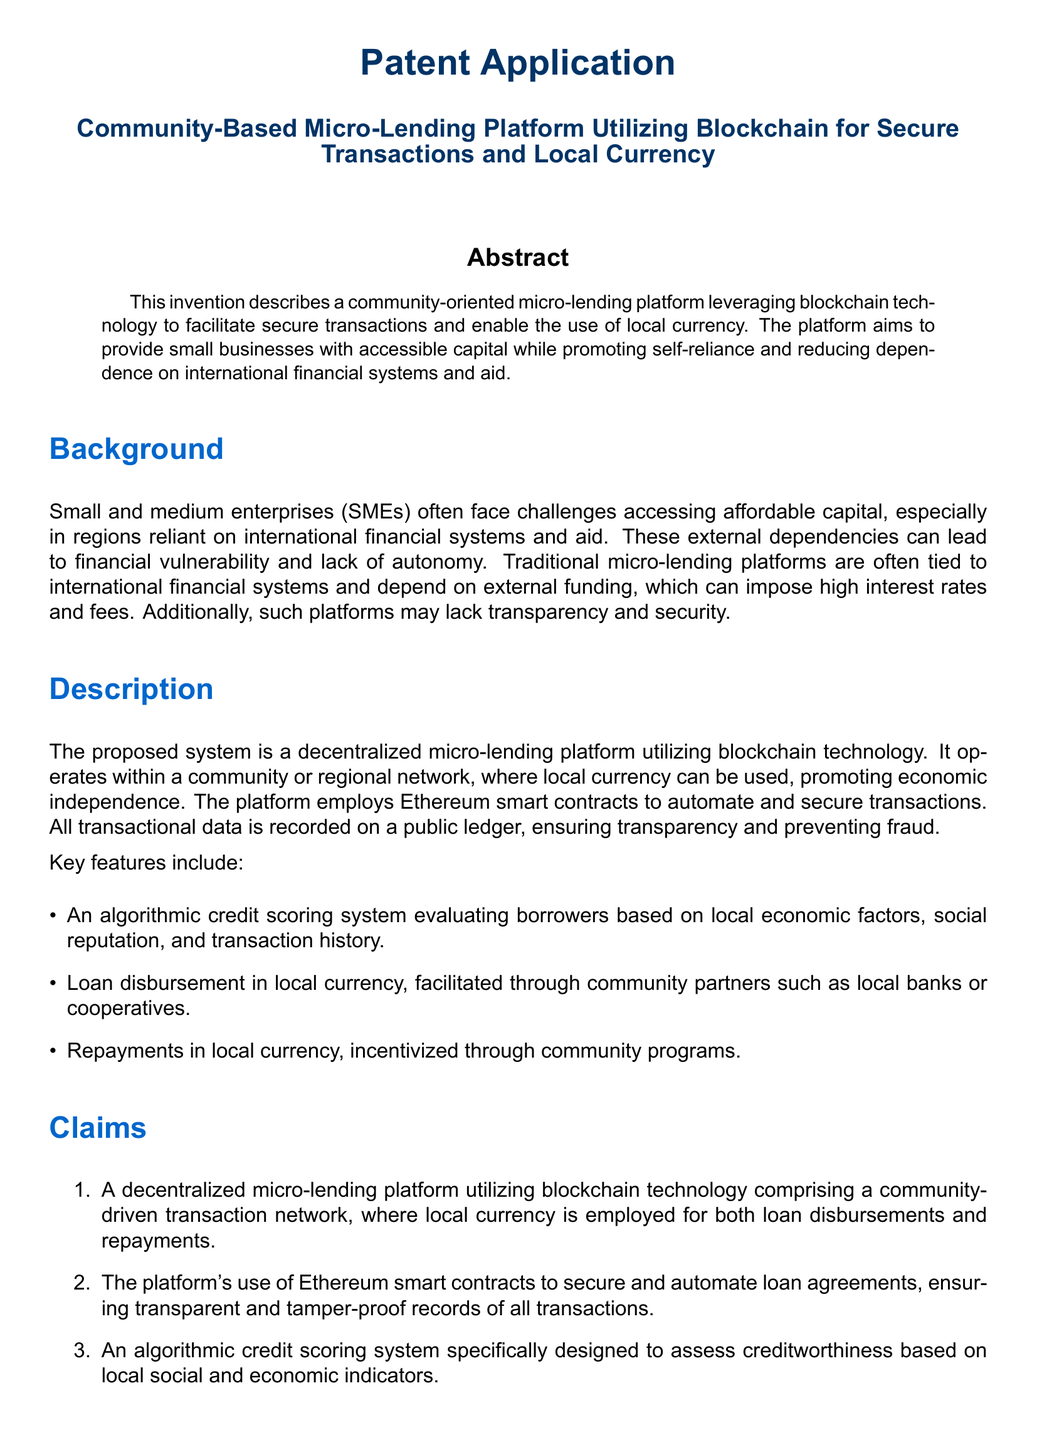What is the title of the patent application? The title is stated at the beginning of the document, introducing the subject matter clearly.
Answer: Community-Based Micro-Lending Platform Utilizing Blockchain for Secure Transactions and Local Currency What technology does the platform utilize? The document specifies the type of technology implemented in the platform, which is important for its functionality.
Answer: Blockchain What is the currency used for loan disbursements? The document highlights the currency context for lending on the platform, which is significant for its operations.
Answer: Local currency What type of algorithm does the platform use for credit scoring? The document mentions a specific feature of the platform that evaluates borrowers, indicating its uniqueness.
Answer: Algorithmic credit scoring system What is a key benefit of the platform mentioned in the claims? One of the claims outlines specific advantages of the platform, showcasing its contributions.
Answer: Economic Independence How does the platform ensure transaction security? The document describes a feature ensuring security in transactions, which is crucial for user trust.
Answer: Ethereum smart contracts What is the primary target of the micro-lending platform? The document identifies the main beneficiaries of the platform, highlighting who will be impacted.
Answer: Small businesses In what city is a real-world example of the platform provided? The example gives a contextual application of the system, showcasing its practical use.
Answer: Nairobi What is the role of community partners in the platform? The document briefly elaborates on how the platform interacts with local entities for its operations.
Answer: Facilitate loan disbursement 